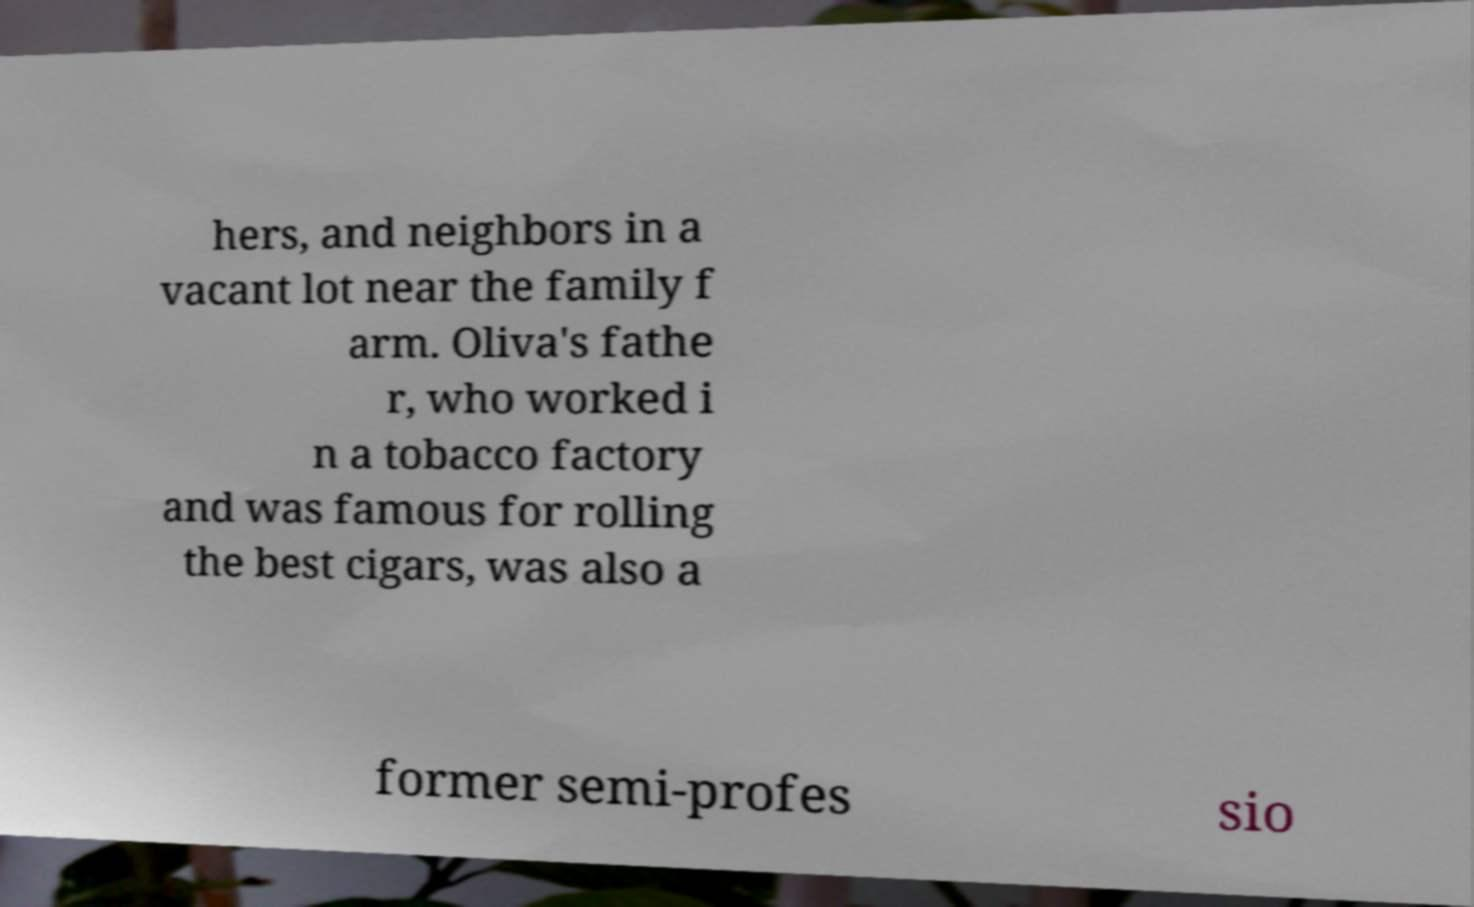I need the written content from this picture converted into text. Can you do that? hers, and neighbors in a vacant lot near the family f arm. Oliva's fathe r, who worked i n a tobacco factory and was famous for rolling the best cigars, was also a former semi-profes sio 